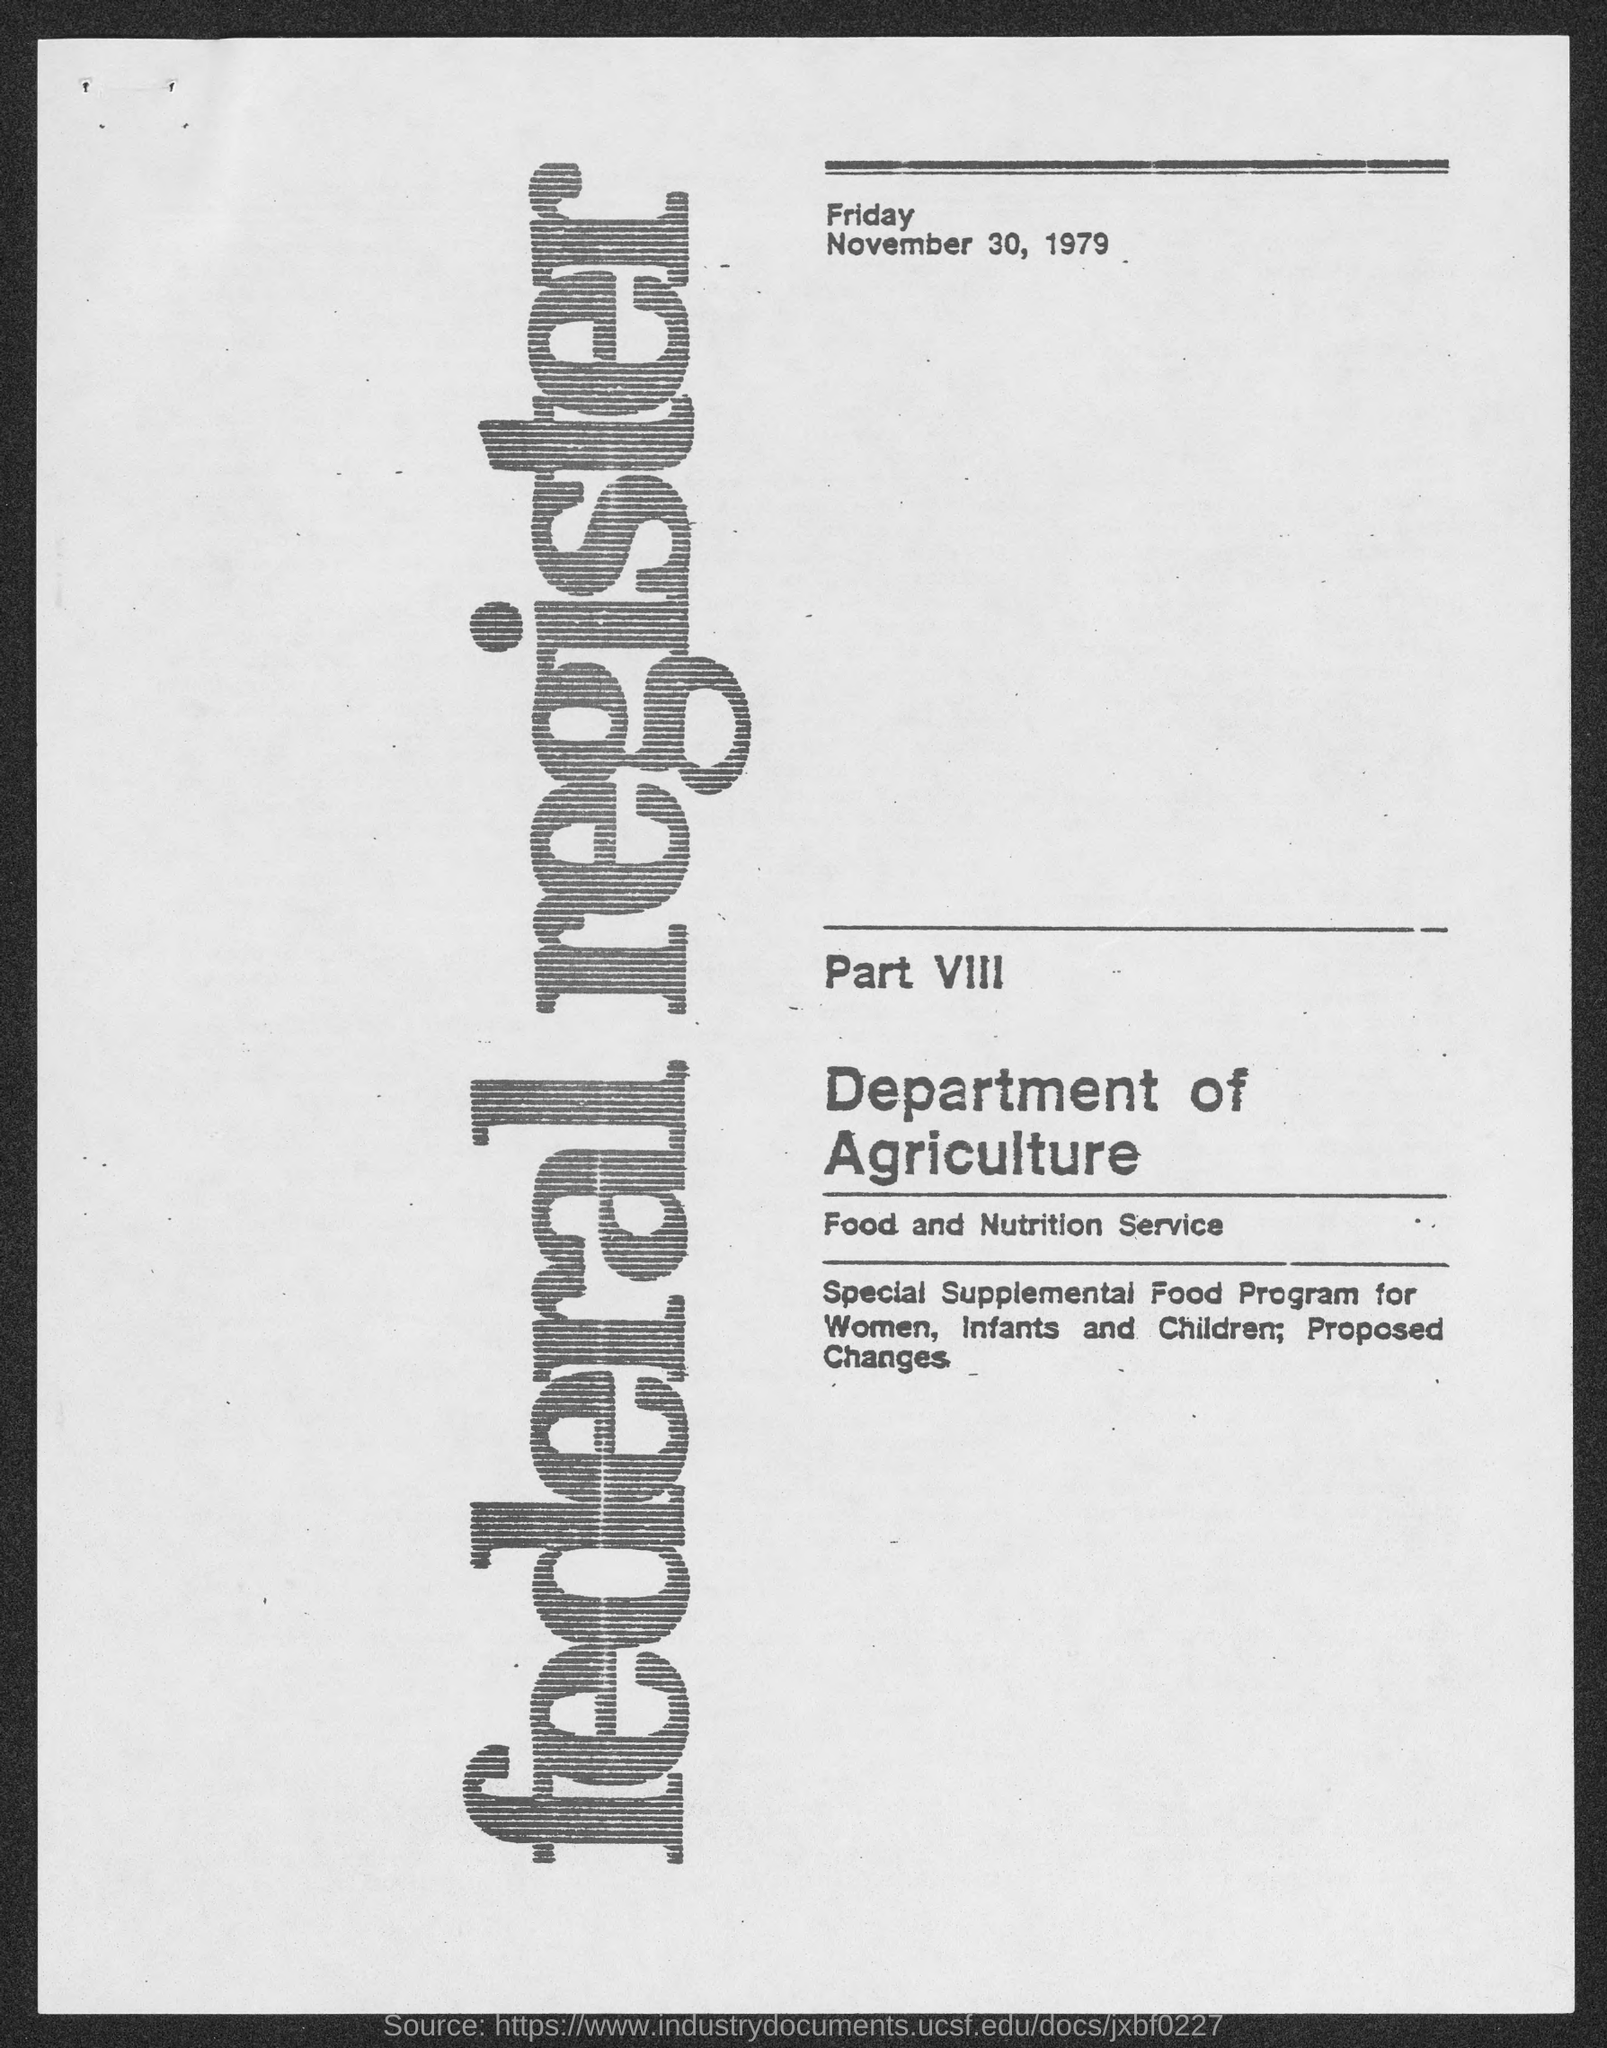Specify some key components in this picture. The day that is mentioned at the top of the document is Friday. The document mentions the Department of Agriculture. The date mentioned below 'Friday' is November 30, 1979. 